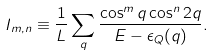Convert formula to latex. <formula><loc_0><loc_0><loc_500><loc_500>I _ { m , n } \equiv \frac { 1 } { L } \sum _ { q } \frac { \cos ^ { m } q \cos ^ { n } 2 q } { E - \epsilon _ { Q } ( q ) } .</formula> 